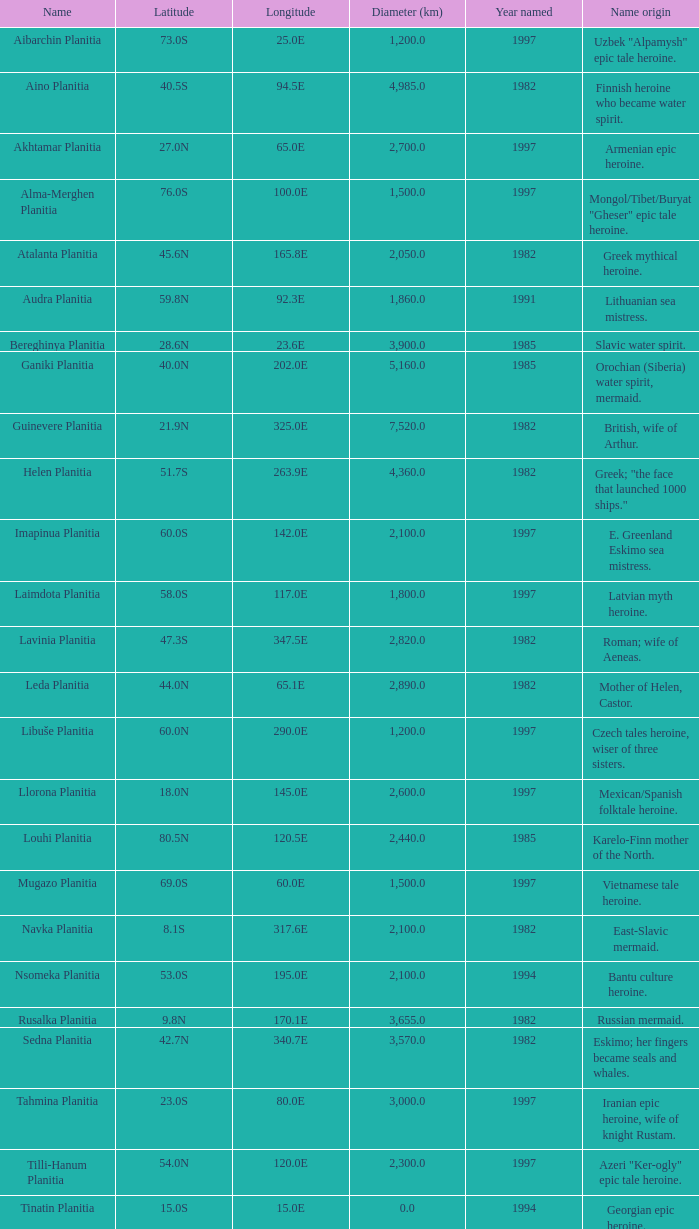What is the diameter (km) of feature of latitude 40.5s 4985.0. 